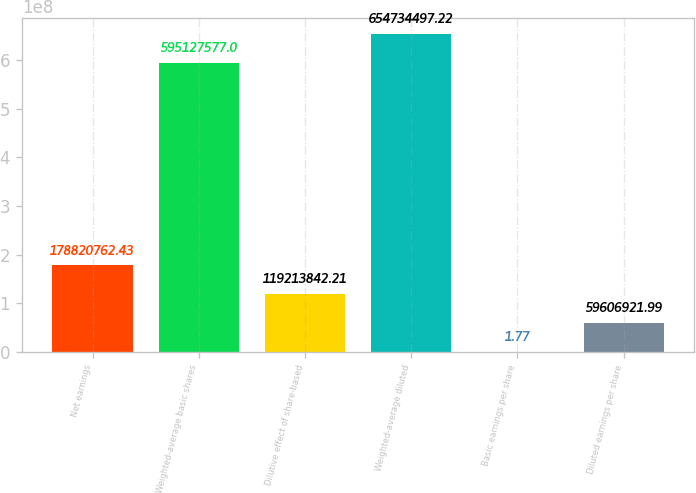<chart> <loc_0><loc_0><loc_500><loc_500><bar_chart><fcel>Net earnings<fcel>Weighted-average basic shares<fcel>Dilutive effect of share-based<fcel>Weighted-average diluted<fcel>Basic earnings per share<fcel>Diluted earnings per share<nl><fcel>1.78821e+08<fcel>5.95128e+08<fcel>1.19214e+08<fcel>6.54734e+08<fcel>1.77<fcel>5.96069e+07<nl></chart> 